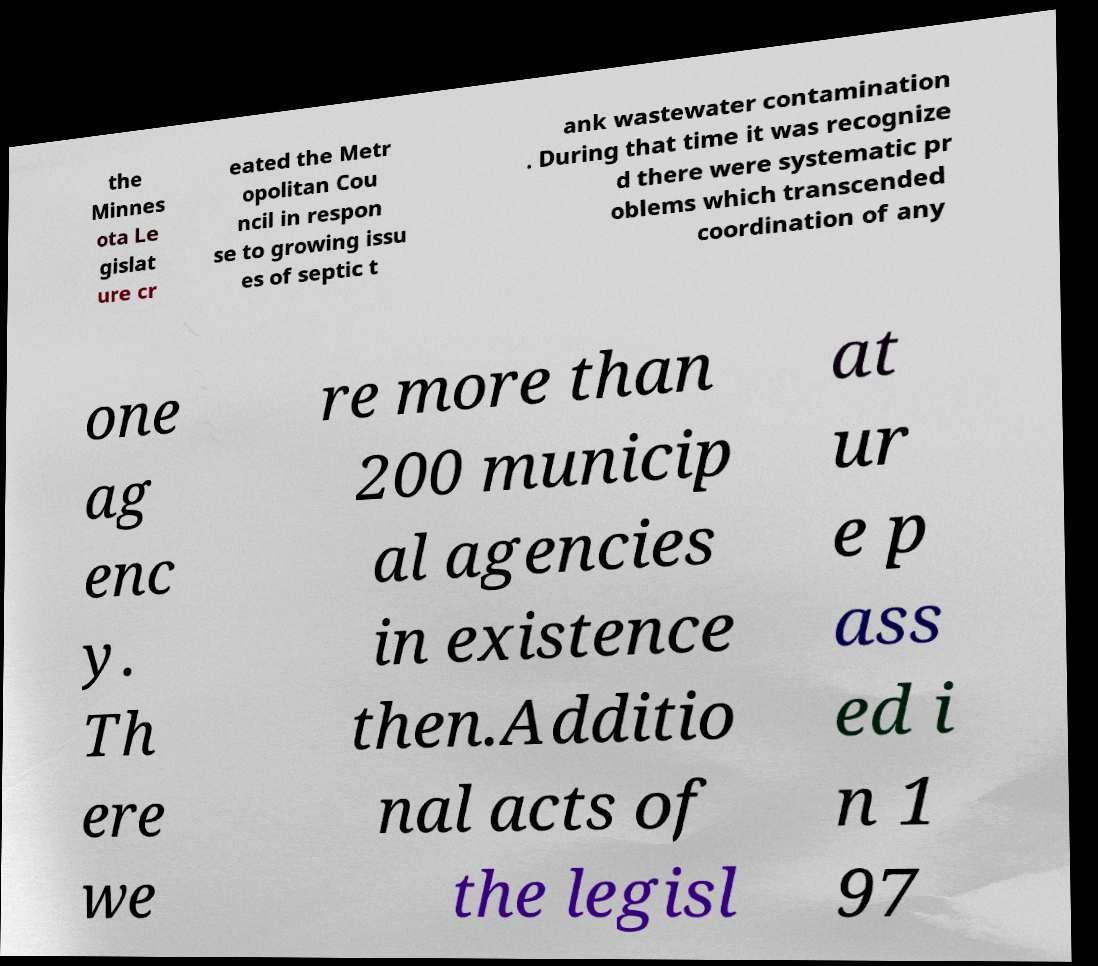Please identify and transcribe the text found in this image. the Minnes ota Le gislat ure cr eated the Metr opolitan Cou ncil in respon se to growing issu es of septic t ank wastewater contamination . During that time it was recognize d there were systematic pr oblems which transcended coordination of any one ag enc y. Th ere we re more than 200 municip al agencies in existence then.Additio nal acts of the legisl at ur e p ass ed i n 1 97 